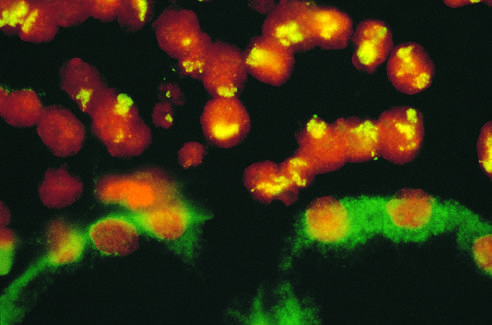s spindle-shaped schwann cells attached to the kidney?
Answer the question using a single word or phrase. No 